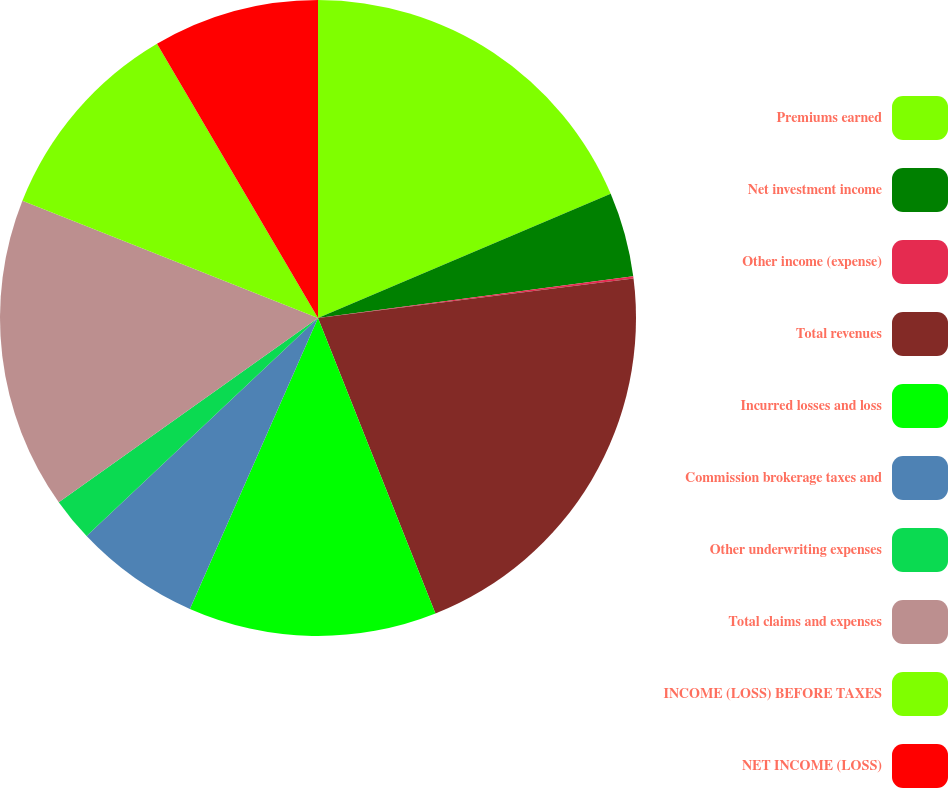Convert chart. <chart><loc_0><loc_0><loc_500><loc_500><pie_chart><fcel>Premiums earned<fcel>Net investment income<fcel>Other income (expense)<fcel>Total revenues<fcel>Incurred losses and loss<fcel>Commission brokerage taxes and<fcel>Other underwriting expenses<fcel>Total claims and expenses<fcel>INCOME (LOSS) BEFORE TAXES<fcel>NET INCOME (LOSS)<nl><fcel>18.61%<fcel>4.29%<fcel>0.12%<fcel>20.96%<fcel>12.62%<fcel>6.37%<fcel>2.2%<fcel>15.84%<fcel>10.54%<fcel>8.45%<nl></chart> 